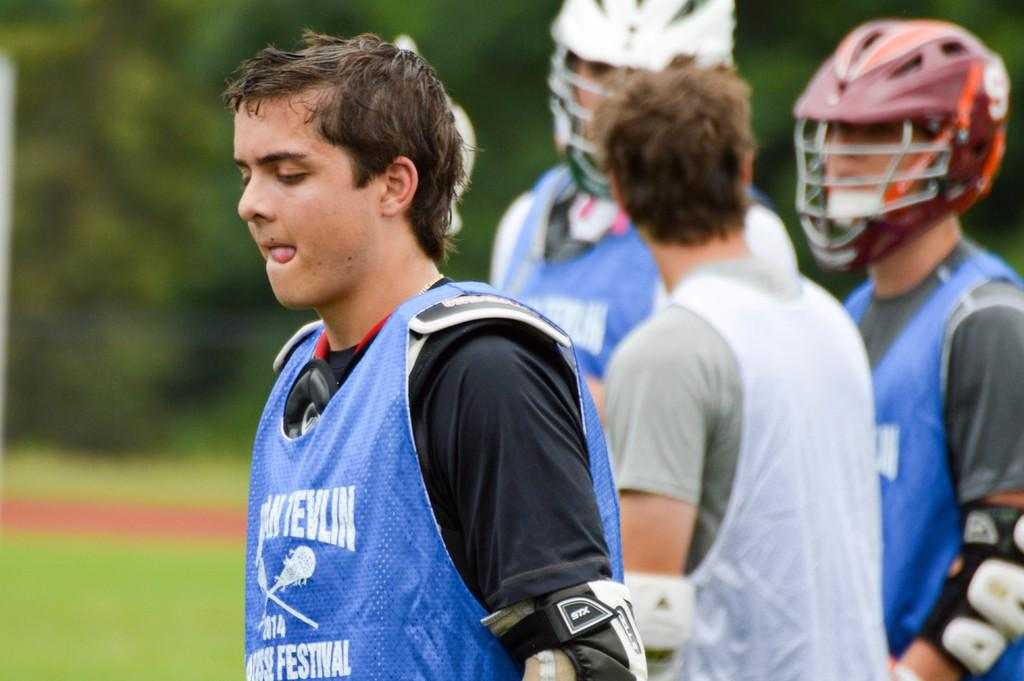What is the main subject of the image? The main subject of the image is a group of people. What can be observed about the attire of some people in the group? Some people in the group are wearing dresses. What specific items are worn by two people in the image? Two people in the image are wearing helmets. What type of natural environment is visible in the background of the image? There are many trees in the background of the image, indicating a natural environment. How is the background of the image depicted? The background is blurred in the image. What type of insurance policy is being discussed by the quince while laughing in the image? There is no quince or discussion of insurance policies in the image; it features a group of people with some wearing dresses and helmets, surrounded by trees in a blurred background. 